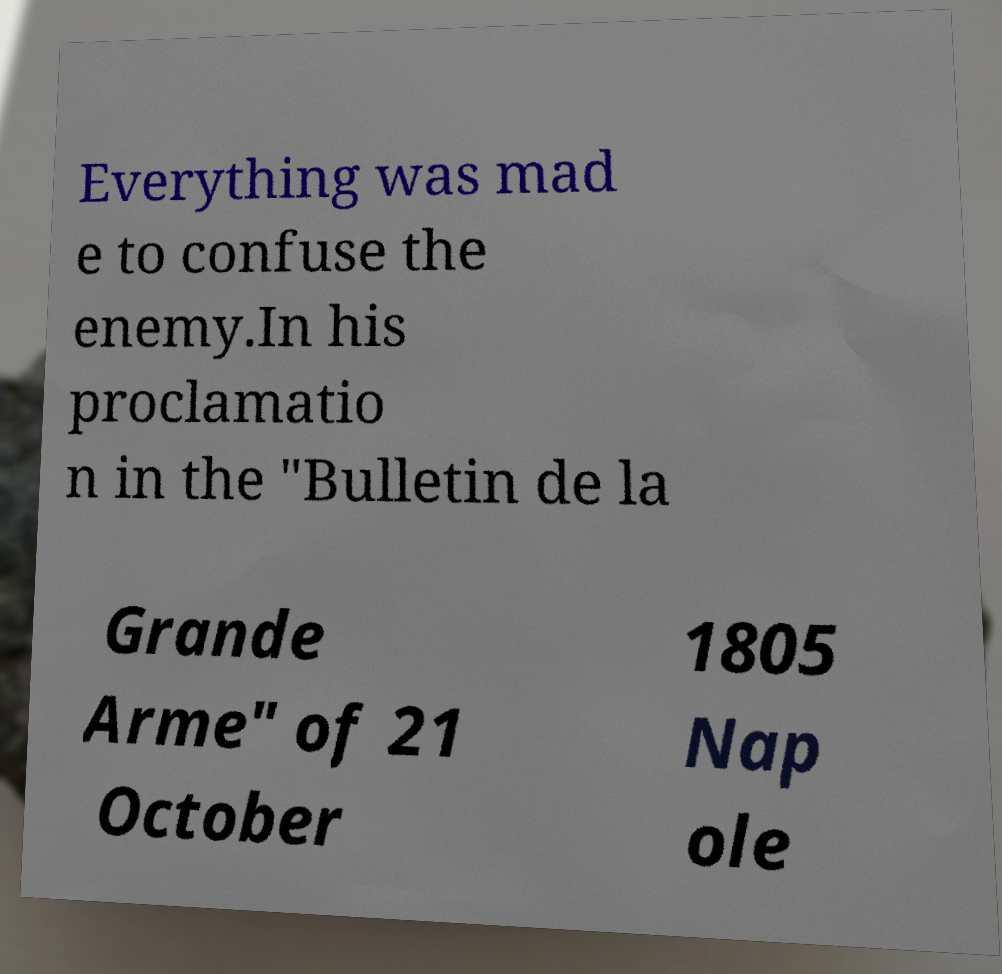Can you accurately transcribe the text from the provided image for me? Everything was mad e to confuse the enemy.In his proclamatio n in the "Bulletin de la Grande Arme" of 21 October 1805 Nap ole 